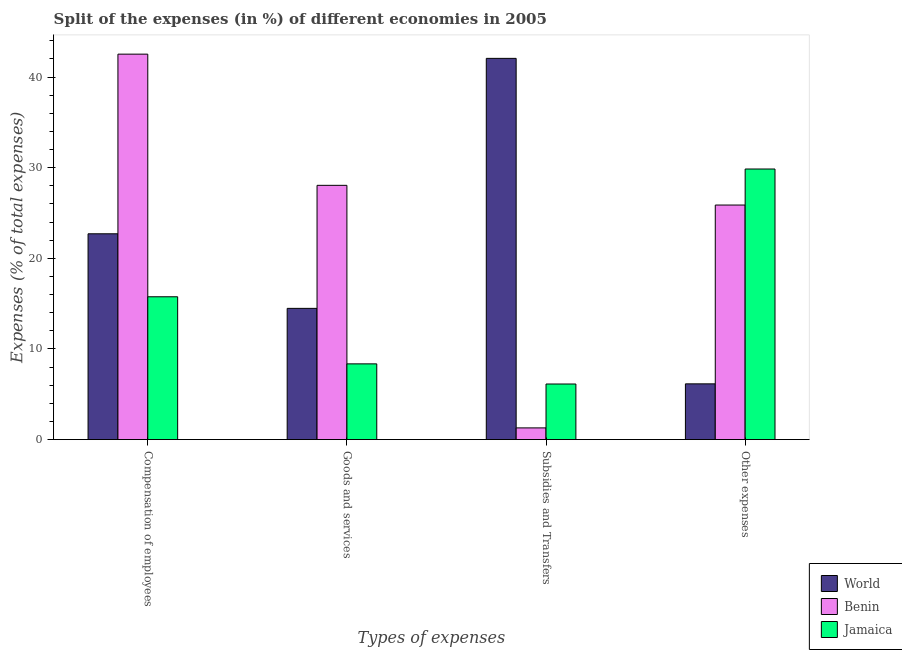How many groups of bars are there?
Your answer should be very brief. 4. Are the number of bars per tick equal to the number of legend labels?
Keep it short and to the point. Yes. How many bars are there on the 3rd tick from the left?
Your response must be concise. 3. How many bars are there on the 2nd tick from the right?
Ensure brevity in your answer.  3. What is the label of the 1st group of bars from the left?
Offer a terse response. Compensation of employees. What is the percentage of amount spent on compensation of employees in World?
Ensure brevity in your answer.  22.71. Across all countries, what is the maximum percentage of amount spent on goods and services?
Provide a succinct answer. 28.05. Across all countries, what is the minimum percentage of amount spent on subsidies?
Your response must be concise. 1.29. In which country was the percentage of amount spent on other expenses maximum?
Your answer should be very brief. Jamaica. In which country was the percentage of amount spent on other expenses minimum?
Your answer should be compact. World. What is the total percentage of amount spent on compensation of employees in the graph?
Your answer should be very brief. 80.99. What is the difference between the percentage of amount spent on other expenses in Jamaica and that in Benin?
Offer a very short reply. 3.97. What is the difference between the percentage of amount spent on compensation of employees in Benin and the percentage of amount spent on other expenses in Jamaica?
Offer a very short reply. 12.67. What is the average percentage of amount spent on other expenses per country?
Give a very brief answer. 20.63. What is the difference between the percentage of amount spent on compensation of employees and percentage of amount spent on other expenses in Benin?
Keep it short and to the point. 16.65. What is the ratio of the percentage of amount spent on subsidies in Benin to that in World?
Offer a very short reply. 0.03. Is the percentage of amount spent on subsidies in World less than that in Jamaica?
Make the answer very short. No. Is the difference between the percentage of amount spent on compensation of employees in Jamaica and World greater than the difference between the percentage of amount spent on goods and services in Jamaica and World?
Keep it short and to the point. No. What is the difference between the highest and the second highest percentage of amount spent on compensation of employees?
Offer a very short reply. 19.82. What is the difference between the highest and the lowest percentage of amount spent on other expenses?
Your response must be concise. 23.7. In how many countries, is the percentage of amount spent on goods and services greater than the average percentage of amount spent on goods and services taken over all countries?
Make the answer very short. 1. Is the sum of the percentage of amount spent on other expenses in Jamaica and Benin greater than the maximum percentage of amount spent on subsidies across all countries?
Make the answer very short. Yes. What does the 3rd bar from the left in Compensation of employees represents?
Ensure brevity in your answer.  Jamaica. Is it the case that in every country, the sum of the percentage of amount spent on compensation of employees and percentage of amount spent on goods and services is greater than the percentage of amount spent on subsidies?
Keep it short and to the point. No. Are all the bars in the graph horizontal?
Your response must be concise. No. How many countries are there in the graph?
Keep it short and to the point. 3. What is the difference between two consecutive major ticks on the Y-axis?
Offer a terse response. 10. Are the values on the major ticks of Y-axis written in scientific E-notation?
Your answer should be very brief. No. Does the graph contain any zero values?
Your answer should be compact. No. Does the graph contain grids?
Keep it short and to the point. No. How many legend labels are there?
Your answer should be compact. 3. How are the legend labels stacked?
Offer a terse response. Vertical. What is the title of the graph?
Ensure brevity in your answer.  Split of the expenses (in %) of different economies in 2005. What is the label or title of the X-axis?
Ensure brevity in your answer.  Types of expenses. What is the label or title of the Y-axis?
Ensure brevity in your answer.  Expenses (% of total expenses). What is the Expenses (% of total expenses) of World in Compensation of employees?
Provide a succinct answer. 22.71. What is the Expenses (% of total expenses) of Benin in Compensation of employees?
Keep it short and to the point. 42.53. What is the Expenses (% of total expenses) in Jamaica in Compensation of employees?
Your response must be concise. 15.76. What is the Expenses (% of total expenses) of World in Goods and services?
Make the answer very short. 14.48. What is the Expenses (% of total expenses) of Benin in Goods and services?
Offer a terse response. 28.05. What is the Expenses (% of total expenses) of Jamaica in Goods and services?
Offer a terse response. 8.36. What is the Expenses (% of total expenses) of World in Subsidies and Transfers?
Keep it short and to the point. 42.06. What is the Expenses (% of total expenses) of Benin in Subsidies and Transfers?
Make the answer very short. 1.29. What is the Expenses (% of total expenses) of Jamaica in Subsidies and Transfers?
Your answer should be very brief. 6.13. What is the Expenses (% of total expenses) in World in Other expenses?
Offer a terse response. 6.15. What is the Expenses (% of total expenses) in Benin in Other expenses?
Ensure brevity in your answer.  25.88. What is the Expenses (% of total expenses) in Jamaica in Other expenses?
Provide a short and direct response. 29.85. Across all Types of expenses, what is the maximum Expenses (% of total expenses) of World?
Your response must be concise. 42.06. Across all Types of expenses, what is the maximum Expenses (% of total expenses) of Benin?
Offer a terse response. 42.53. Across all Types of expenses, what is the maximum Expenses (% of total expenses) of Jamaica?
Ensure brevity in your answer.  29.85. Across all Types of expenses, what is the minimum Expenses (% of total expenses) in World?
Offer a terse response. 6.15. Across all Types of expenses, what is the minimum Expenses (% of total expenses) in Benin?
Ensure brevity in your answer.  1.29. Across all Types of expenses, what is the minimum Expenses (% of total expenses) of Jamaica?
Offer a terse response. 6.13. What is the total Expenses (% of total expenses) of World in the graph?
Your answer should be compact. 85.4. What is the total Expenses (% of total expenses) of Benin in the graph?
Your response must be concise. 97.75. What is the total Expenses (% of total expenses) of Jamaica in the graph?
Ensure brevity in your answer.  60.1. What is the difference between the Expenses (% of total expenses) of World in Compensation of employees and that in Goods and services?
Your answer should be very brief. 8.23. What is the difference between the Expenses (% of total expenses) in Benin in Compensation of employees and that in Goods and services?
Your answer should be compact. 14.47. What is the difference between the Expenses (% of total expenses) in Jamaica in Compensation of employees and that in Goods and services?
Your response must be concise. 7.4. What is the difference between the Expenses (% of total expenses) of World in Compensation of employees and that in Subsidies and Transfers?
Give a very brief answer. -19.35. What is the difference between the Expenses (% of total expenses) of Benin in Compensation of employees and that in Subsidies and Transfers?
Ensure brevity in your answer.  41.24. What is the difference between the Expenses (% of total expenses) in Jamaica in Compensation of employees and that in Subsidies and Transfers?
Keep it short and to the point. 9.62. What is the difference between the Expenses (% of total expenses) of World in Compensation of employees and that in Other expenses?
Your answer should be very brief. 16.56. What is the difference between the Expenses (% of total expenses) in Benin in Compensation of employees and that in Other expenses?
Provide a succinct answer. 16.65. What is the difference between the Expenses (% of total expenses) of Jamaica in Compensation of employees and that in Other expenses?
Offer a terse response. -14.1. What is the difference between the Expenses (% of total expenses) of World in Goods and services and that in Subsidies and Transfers?
Make the answer very short. -27.58. What is the difference between the Expenses (% of total expenses) of Benin in Goods and services and that in Subsidies and Transfers?
Your answer should be very brief. 26.76. What is the difference between the Expenses (% of total expenses) in Jamaica in Goods and services and that in Subsidies and Transfers?
Make the answer very short. 2.22. What is the difference between the Expenses (% of total expenses) in World in Goods and services and that in Other expenses?
Offer a terse response. 8.33. What is the difference between the Expenses (% of total expenses) in Benin in Goods and services and that in Other expenses?
Give a very brief answer. 2.17. What is the difference between the Expenses (% of total expenses) in Jamaica in Goods and services and that in Other expenses?
Make the answer very short. -21.5. What is the difference between the Expenses (% of total expenses) in World in Subsidies and Transfers and that in Other expenses?
Ensure brevity in your answer.  35.91. What is the difference between the Expenses (% of total expenses) in Benin in Subsidies and Transfers and that in Other expenses?
Offer a very short reply. -24.59. What is the difference between the Expenses (% of total expenses) of Jamaica in Subsidies and Transfers and that in Other expenses?
Provide a short and direct response. -23.72. What is the difference between the Expenses (% of total expenses) in World in Compensation of employees and the Expenses (% of total expenses) in Benin in Goods and services?
Keep it short and to the point. -5.35. What is the difference between the Expenses (% of total expenses) of World in Compensation of employees and the Expenses (% of total expenses) of Jamaica in Goods and services?
Your response must be concise. 14.35. What is the difference between the Expenses (% of total expenses) in Benin in Compensation of employees and the Expenses (% of total expenses) in Jamaica in Goods and services?
Provide a succinct answer. 34.17. What is the difference between the Expenses (% of total expenses) in World in Compensation of employees and the Expenses (% of total expenses) in Benin in Subsidies and Transfers?
Your answer should be very brief. 21.42. What is the difference between the Expenses (% of total expenses) in World in Compensation of employees and the Expenses (% of total expenses) in Jamaica in Subsidies and Transfers?
Offer a terse response. 16.57. What is the difference between the Expenses (% of total expenses) in Benin in Compensation of employees and the Expenses (% of total expenses) in Jamaica in Subsidies and Transfers?
Ensure brevity in your answer.  36.39. What is the difference between the Expenses (% of total expenses) in World in Compensation of employees and the Expenses (% of total expenses) in Benin in Other expenses?
Provide a succinct answer. -3.17. What is the difference between the Expenses (% of total expenses) in World in Compensation of employees and the Expenses (% of total expenses) in Jamaica in Other expenses?
Give a very brief answer. -7.15. What is the difference between the Expenses (% of total expenses) in Benin in Compensation of employees and the Expenses (% of total expenses) in Jamaica in Other expenses?
Provide a succinct answer. 12.67. What is the difference between the Expenses (% of total expenses) in World in Goods and services and the Expenses (% of total expenses) in Benin in Subsidies and Transfers?
Offer a terse response. 13.19. What is the difference between the Expenses (% of total expenses) in World in Goods and services and the Expenses (% of total expenses) in Jamaica in Subsidies and Transfers?
Provide a succinct answer. 8.35. What is the difference between the Expenses (% of total expenses) in Benin in Goods and services and the Expenses (% of total expenses) in Jamaica in Subsidies and Transfers?
Your answer should be very brief. 21.92. What is the difference between the Expenses (% of total expenses) of World in Goods and services and the Expenses (% of total expenses) of Benin in Other expenses?
Make the answer very short. -11.4. What is the difference between the Expenses (% of total expenses) of World in Goods and services and the Expenses (% of total expenses) of Jamaica in Other expenses?
Your response must be concise. -15.38. What is the difference between the Expenses (% of total expenses) in Benin in Goods and services and the Expenses (% of total expenses) in Jamaica in Other expenses?
Keep it short and to the point. -1.8. What is the difference between the Expenses (% of total expenses) of World in Subsidies and Transfers and the Expenses (% of total expenses) of Benin in Other expenses?
Keep it short and to the point. 16.18. What is the difference between the Expenses (% of total expenses) of World in Subsidies and Transfers and the Expenses (% of total expenses) of Jamaica in Other expenses?
Keep it short and to the point. 12.21. What is the difference between the Expenses (% of total expenses) of Benin in Subsidies and Transfers and the Expenses (% of total expenses) of Jamaica in Other expenses?
Provide a short and direct response. -28.56. What is the average Expenses (% of total expenses) in World per Types of expenses?
Provide a succinct answer. 21.35. What is the average Expenses (% of total expenses) of Benin per Types of expenses?
Make the answer very short. 24.44. What is the average Expenses (% of total expenses) in Jamaica per Types of expenses?
Provide a succinct answer. 15.03. What is the difference between the Expenses (% of total expenses) in World and Expenses (% of total expenses) in Benin in Compensation of employees?
Offer a terse response. -19.82. What is the difference between the Expenses (% of total expenses) of World and Expenses (% of total expenses) of Jamaica in Compensation of employees?
Provide a succinct answer. 6.95. What is the difference between the Expenses (% of total expenses) of Benin and Expenses (% of total expenses) of Jamaica in Compensation of employees?
Ensure brevity in your answer.  26.77. What is the difference between the Expenses (% of total expenses) in World and Expenses (% of total expenses) in Benin in Goods and services?
Give a very brief answer. -13.57. What is the difference between the Expenses (% of total expenses) in World and Expenses (% of total expenses) in Jamaica in Goods and services?
Provide a succinct answer. 6.12. What is the difference between the Expenses (% of total expenses) of Benin and Expenses (% of total expenses) of Jamaica in Goods and services?
Keep it short and to the point. 19.7. What is the difference between the Expenses (% of total expenses) in World and Expenses (% of total expenses) in Benin in Subsidies and Transfers?
Provide a short and direct response. 40.77. What is the difference between the Expenses (% of total expenses) of World and Expenses (% of total expenses) of Jamaica in Subsidies and Transfers?
Provide a succinct answer. 35.93. What is the difference between the Expenses (% of total expenses) of Benin and Expenses (% of total expenses) of Jamaica in Subsidies and Transfers?
Keep it short and to the point. -4.84. What is the difference between the Expenses (% of total expenses) of World and Expenses (% of total expenses) of Benin in Other expenses?
Your answer should be very brief. -19.73. What is the difference between the Expenses (% of total expenses) of World and Expenses (% of total expenses) of Jamaica in Other expenses?
Your response must be concise. -23.7. What is the difference between the Expenses (% of total expenses) of Benin and Expenses (% of total expenses) of Jamaica in Other expenses?
Keep it short and to the point. -3.97. What is the ratio of the Expenses (% of total expenses) in World in Compensation of employees to that in Goods and services?
Offer a terse response. 1.57. What is the ratio of the Expenses (% of total expenses) in Benin in Compensation of employees to that in Goods and services?
Give a very brief answer. 1.52. What is the ratio of the Expenses (% of total expenses) of Jamaica in Compensation of employees to that in Goods and services?
Provide a short and direct response. 1.89. What is the ratio of the Expenses (% of total expenses) of World in Compensation of employees to that in Subsidies and Transfers?
Give a very brief answer. 0.54. What is the ratio of the Expenses (% of total expenses) of Benin in Compensation of employees to that in Subsidies and Transfers?
Offer a terse response. 32.93. What is the ratio of the Expenses (% of total expenses) in Jamaica in Compensation of employees to that in Subsidies and Transfers?
Your answer should be compact. 2.57. What is the ratio of the Expenses (% of total expenses) of World in Compensation of employees to that in Other expenses?
Keep it short and to the point. 3.69. What is the ratio of the Expenses (% of total expenses) of Benin in Compensation of employees to that in Other expenses?
Your response must be concise. 1.64. What is the ratio of the Expenses (% of total expenses) in Jamaica in Compensation of employees to that in Other expenses?
Offer a very short reply. 0.53. What is the ratio of the Expenses (% of total expenses) of World in Goods and services to that in Subsidies and Transfers?
Make the answer very short. 0.34. What is the ratio of the Expenses (% of total expenses) in Benin in Goods and services to that in Subsidies and Transfers?
Ensure brevity in your answer.  21.72. What is the ratio of the Expenses (% of total expenses) in Jamaica in Goods and services to that in Subsidies and Transfers?
Give a very brief answer. 1.36. What is the ratio of the Expenses (% of total expenses) in World in Goods and services to that in Other expenses?
Ensure brevity in your answer.  2.35. What is the ratio of the Expenses (% of total expenses) in Benin in Goods and services to that in Other expenses?
Your answer should be very brief. 1.08. What is the ratio of the Expenses (% of total expenses) of Jamaica in Goods and services to that in Other expenses?
Provide a succinct answer. 0.28. What is the ratio of the Expenses (% of total expenses) of World in Subsidies and Transfers to that in Other expenses?
Make the answer very short. 6.84. What is the ratio of the Expenses (% of total expenses) of Benin in Subsidies and Transfers to that in Other expenses?
Give a very brief answer. 0.05. What is the ratio of the Expenses (% of total expenses) of Jamaica in Subsidies and Transfers to that in Other expenses?
Your answer should be compact. 0.21. What is the difference between the highest and the second highest Expenses (% of total expenses) of World?
Your answer should be very brief. 19.35. What is the difference between the highest and the second highest Expenses (% of total expenses) of Benin?
Your answer should be very brief. 14.47. What is the difference between the highest and the second highest Expenses (% of total expenses) of Jamaica?
Offer a very short reply. 14.1. What is the difference between the highest and the lowest Expenses (% of total expenses) in World?
Offer a terse response. 35.91. What is the difference between the highest and the lowest Expenses (% of total expenses) of Benin?
Offer a terse response. 41.24. What is the difference between the highest and the lowest Expenses (% of total expenses) of Jamaica?
Your answer should be very brief. 23.72. 